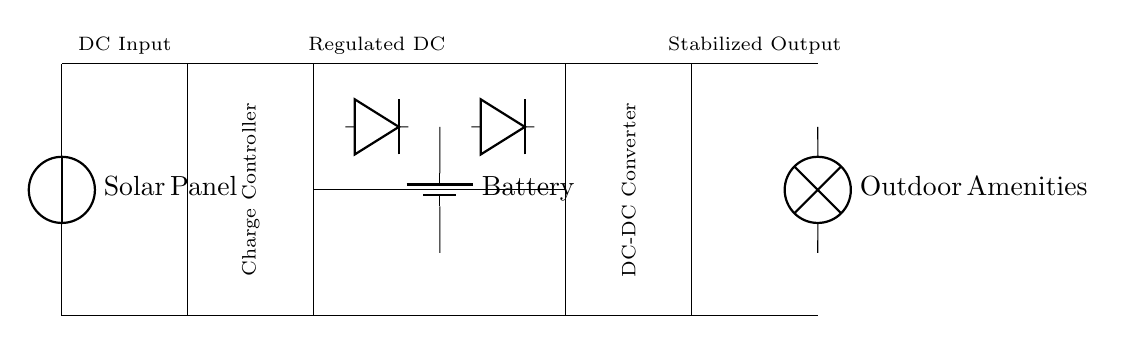What component converts solar energy to electrical energy? The solar panel is the component responsible for converting solar energy into electrical energy, demonstrated as a voltage source in the diagram.
Answer: Solar Panel What is the role of the charge controller? The charge controller regulates the voltage and current coming from the solar panel to the battery, preventing overcharging. It is shown as a rectangle labeled "Charge Controller" in the circuit.
Answer: Regulate What type of load is shown in the circuit? The load depicted is represented by the lamp symbol, which indicates the use of electrical energy for outdoor amenities such as lights or charging stations.
Answer: Outdoor Amenities How many diodes are present in the circuit? There are two diodes in the circuit controlling the current direction, placed between the charge controller and the battery, as well as between the battery and the DC-DC converter.
Answer: Two What does the DC-DC converter do in this circuit? The DC-DC converter adjusts the voltage levels to provide a stabilized output for the load, ensuring that the outdoor amenities receive the appropriate voltage.
Answer: Adjust Voltage What is the output connection labeled as? The output connection is labeled as "Stabilized Output," indicating the provided voltage to the connected load after regulation by the DC-DC converter.
Answer: Stabilized Output 